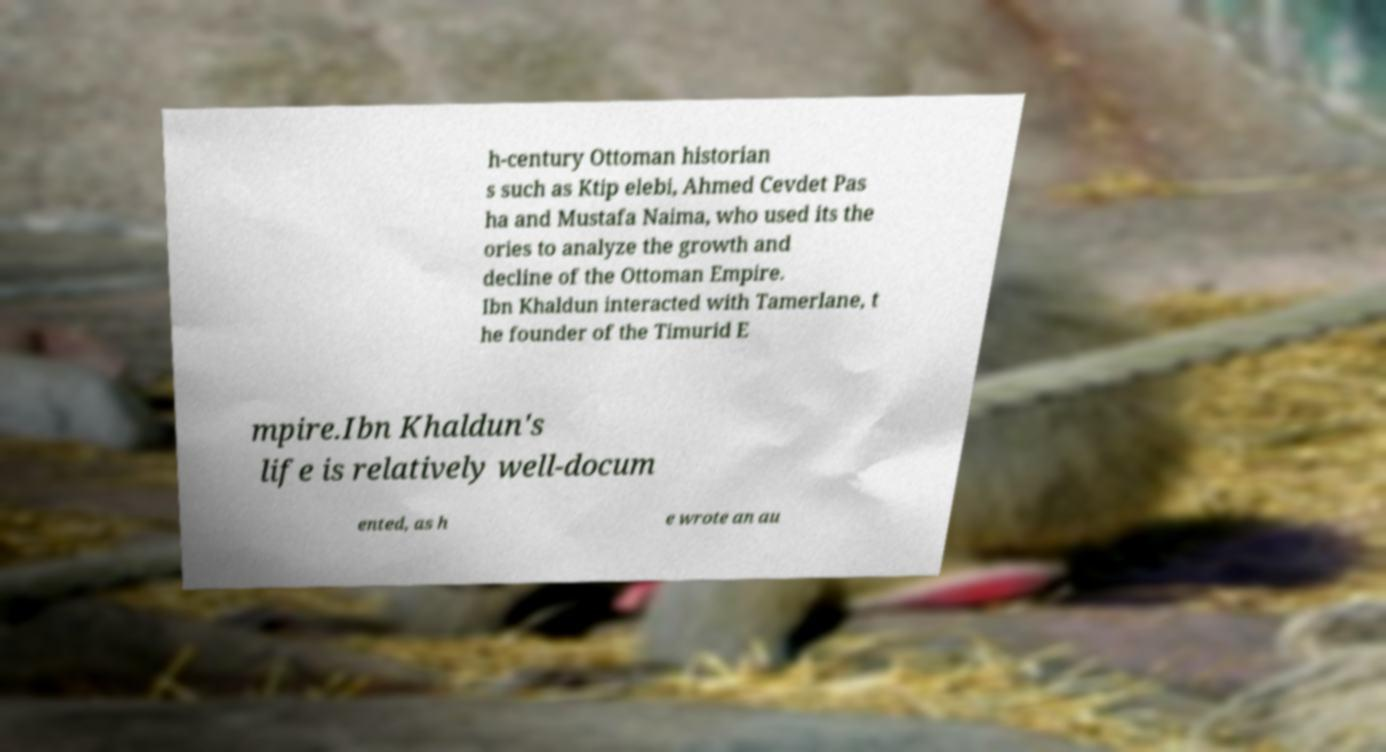Could you assist in decoding the text presented in this image and type it out clearly? h-century Ottoman historian s such as Ktip elebi, Ahmed Cevdet Pas ha and Mustafa Naima, who used its the ories to analyze the growth and decline of the Ottoman Empire. Ibn Khaldun interacted with Tamerlane, t he founder of the Timurid E mpire.Ibn Khaldun's life is relatively well-docum ented, as h e wrote an au 